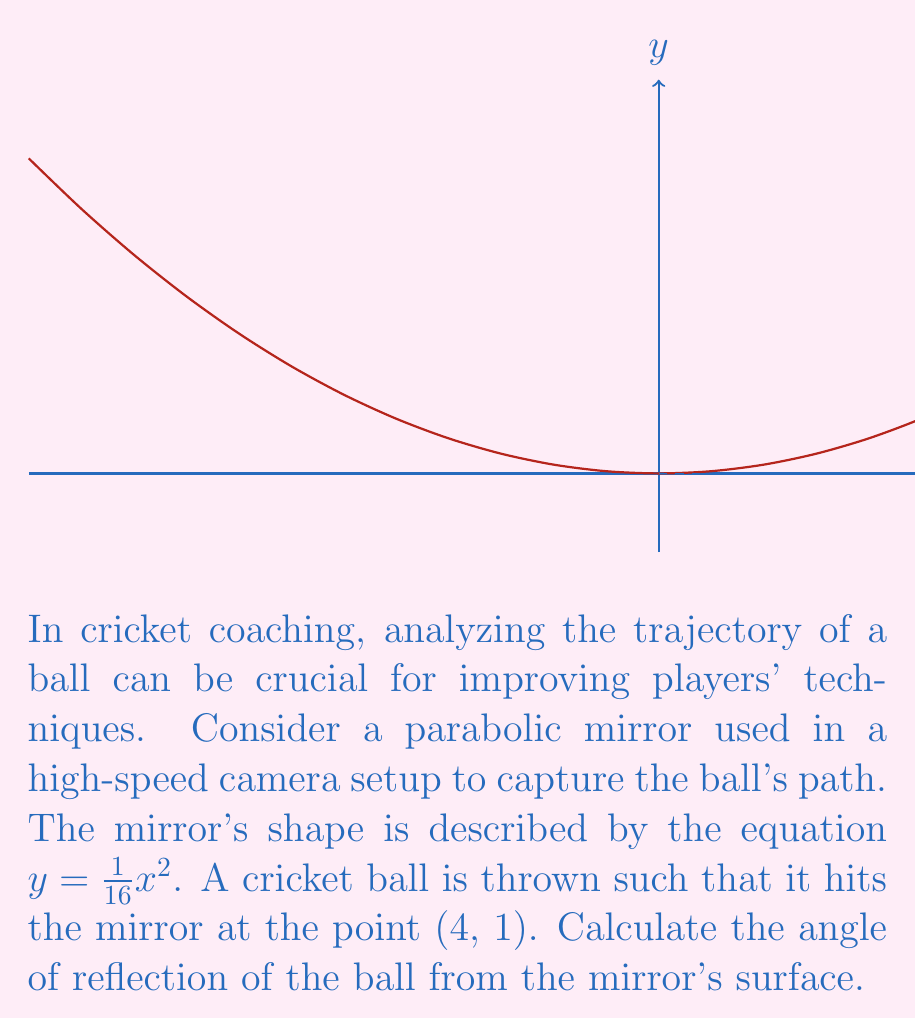Can you answer this question? Let's approach this step-by-step:

1) The angle of reflection is equal to the angle of incidence. Both are measured from the normal line to the surface at the point of reflection.

2) To find the normal line, we need to find the tangent line to the parabola at the point (4, 1) and then get its perpendicular.

3) The derivative of $y = \frac{1}{16}x^2$ is $y' = \frac{1}{8}x$.

4) At x = 4, the slope of the tangent line is:
   $y'(4) = \frac{1}{8}(4) = \frac{1}{2}$

5) The equation of the tangent line is:
   $y - 1 = \frac{1}{2}(x - 4)$

6) The normal line is perpendicular to the tangent line. The product of their slopes is -1. So, the slope of the normal line is -2.

7) The equation of the normal line is:
   $y - 1 = -2(x - 4)$

8) The angle between the normal line and the y-axis is the same as the angle between the normal line and the x-axis. Let's call this angle $\theta$.

9) $\tan(\theta) = \frac{1}{2}$ (absolute value of the reciprocal of the normal line's slope)

10) Therefore, $\theta = \arctan(\frac{1}{2}) \approx 26.57°$

11) The angle of reflection (and incidence) is the complement of this angle:
    $90° - 26.57° = 63.43°$
Answer: $63.43°$ 